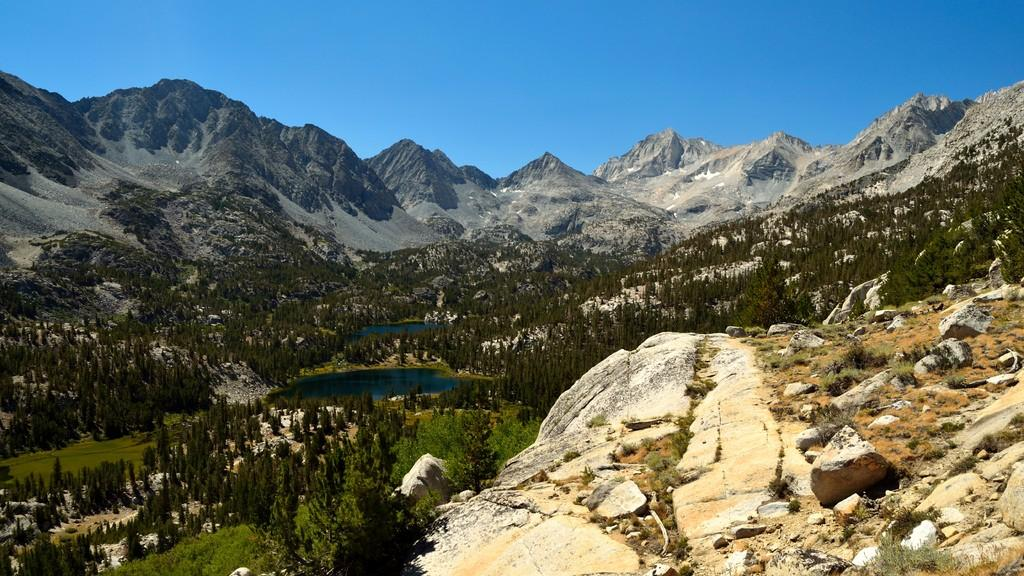What type of natural elements can be seen in the image? There are rocks, trees, and water visible in the image. What type of landscape feature is present in the image? There are mountains in the image. What is visible in the background of the image? The sky is visible in the background of the image. What type of doctor is examining the rocks in the image? There is no doctor present in the image, and the rocks are not being examined by anyone. 